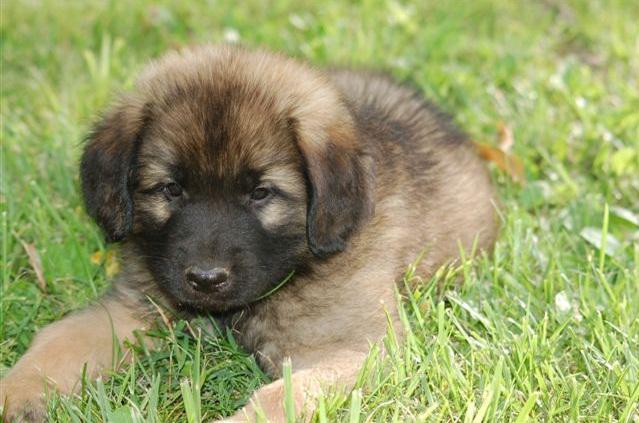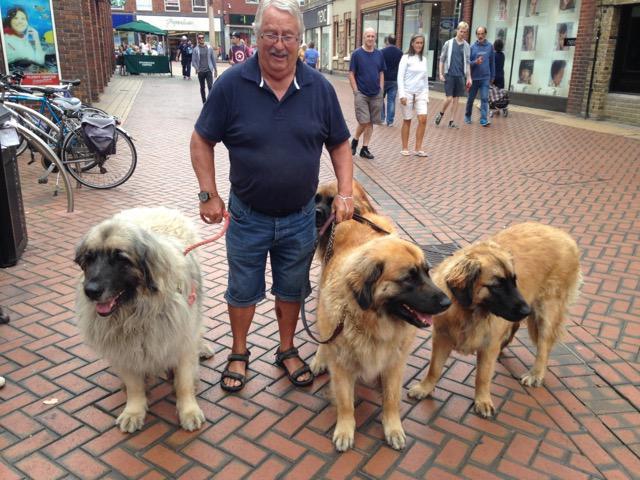The first image is the image on the left, the second image is the image on the right. Considering the images on both sides, is "In one of the images, a human can be seen walking at least one dog." valid? Answer yes or no. Yes. The first image is the image on the left, the second image is the image on the right. Assess this claim about the two images: "One image has a person standing next to a dog in the city.". Correct or not? Answer yes or no. Yes. 